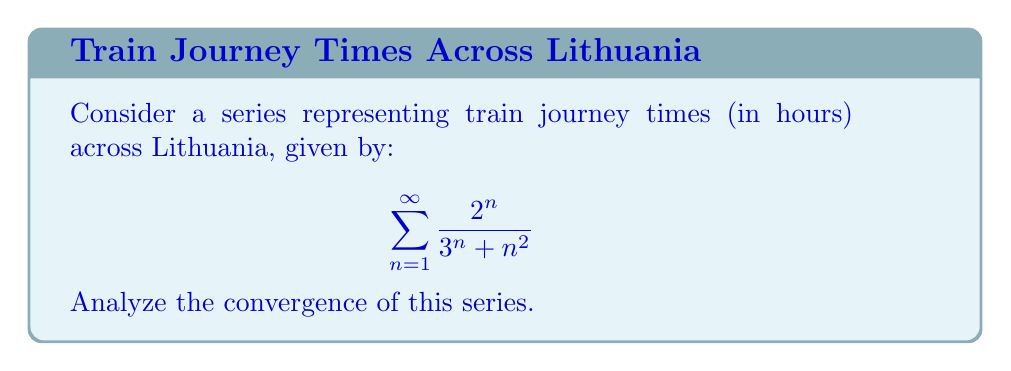What is the answer to this math problem? To analyze the convergence of this series, we'll use the ratio test:

1) Let $a_n = \frac{2^n}{3^n + n^2}$

2) Form the ratio $\frac{a_{n+1}}{a_n}$:

   $$\frac{a_{n+1}}{a_n} = \frac{\frac{2^{n+1}}{3^{n+1} + (n+1)^2}}{\frac{2^n}{3^n + n^2}}$$

3) Simplify:
   
   $$\frac{a_{n+1}}{a_n} = \frac{2^{n+1}}{2^n} \cdot \frac{3^n + n^2}{3^{n+1} + (n+1)^2}$$
   
   $$= 2 \cdot \frac{3^n + n^2}{3^{n+1} + (n+1)^2}$$

4) Take the limit as $n$ approaches infinity:

   $$\lim_{n \to \infty} \frac{a_{n+1}}{a_n} = \lim_{n \to \infty} 2 \cdot \frac{3^n + n^2}{3^{n+1} + (n+1)^2}$$
   
   $$= 2 \cdot \lim_{n \to \infty} \frac{3^n + n^2}{3 \cdot 3^n + (n+1)^2}$$
   
   $$= 2 \cdot \frac{1}{3} = \frac{2}{3}$$

5) Since the limit is less than 1, by the ratio test, the series converges.
Answer: The series converges. 